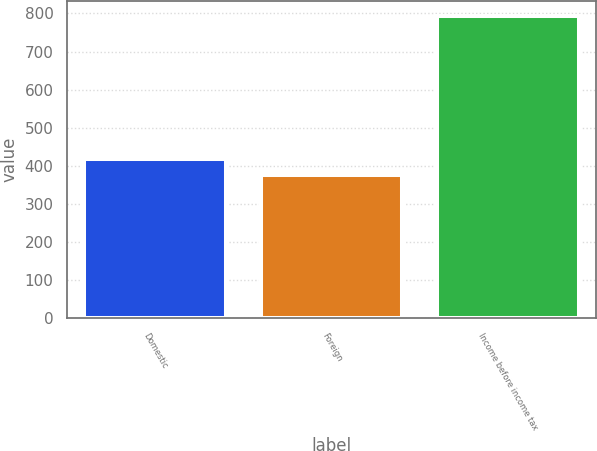Convert chart to OTSL. <chart><loc_0><loc_0><loc_500><loc_500><bar_chart><fcel>Domestic<fcel>Foreign<fcel>Income before income tax<nl><fcel>418<fcel>376<fcel>794<nl></chart> 